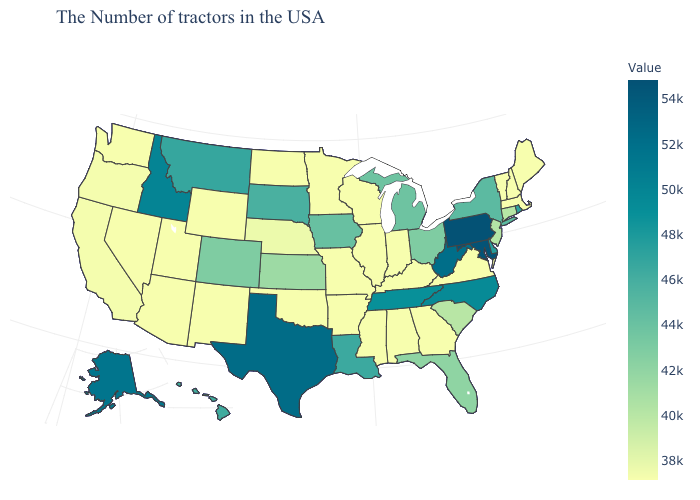Among the states that border Delaware , does Pennsylvania have the highest value?
Be succinct. Yes. Is the legend a continuous bar?
Keep it brief. Yes. Does Maine have the lowest value in the USA?
Answer briefly. Yes. Does Rhode Island have the lowest value in the USA?
Answer briefly. No. 